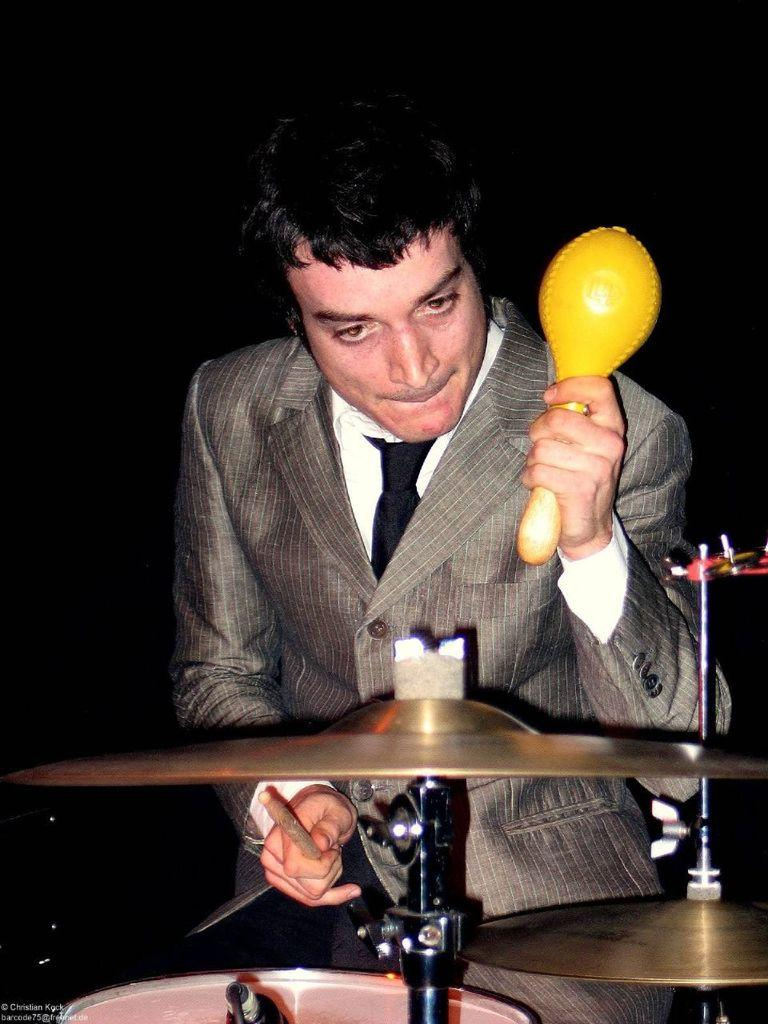Who is the person in the image? There is a man in the image. What is the man doing in the image? The man is standing and playing the drum set. What is in front of the man? There is a drum set in front of the man. What type of throat lozenges can be seen on the edge of the drum set in the image? There are no throat lozenges or any other items visible on the edge of the drum set in the image. 